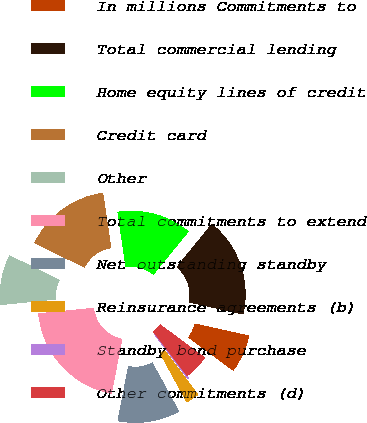Convert chart to OTSL. <chart><loc_0><loc_0><loc_500><loc_500><pie_chart><fcel>In millions Commitments to<fcel>Total commercial lending<fcel>Home equity lines of credit<fcel>Credit card<fcel>Other<fcel>Total commitments to extend<fcel>Net outstanding standby<fcel>Reinsurance agreements (b)<fcel>Standby bond purchase<fcel>Other commitments (d)<nl><fcel>6.67%<fcel>17.6%<fcel>13.22%<fcel>15.41%<fcel>8.85%<fcel>20.33%<fcel>11.04%<fcel>2.29%<fcel>0.11%<fcel>4.48%<nl></chart> 